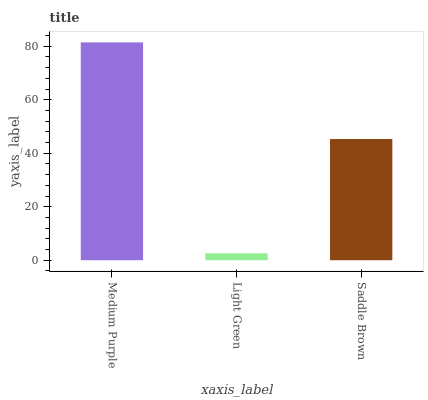Is Light Green the minimum?
Answer yes or no. Yes. Is Medium Purple the maximum?
Answer yes or no. Yes. Is Saddle Brown the minimum?
Answer yes or no. No. Is Saddle Brown the maximum?
Answer yes or no. No. Is Saddle Brown greater than Light Green?
Answer yes or no. Yes. Is Light Green less than Saddle Brown?
Answer yes or no. Yes. Is Light Green greater than Saddle Brown?
Answer yes or no. No. Is Saddle Brown less than Light Green?
Answer yes or no. No. Is Saddle Brown the high median?
Answer yes or no. Yes. Is Saddle Brown the low median?
Answer yes or no. Yes. Is Medium Purple the high median?
Answer yes or no. No. Is Medium Purple the low median?
Answer yes or no. No. 